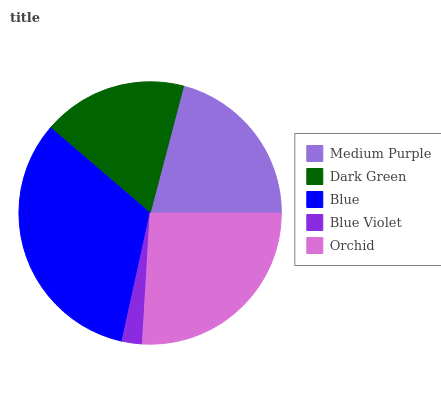Is Blue Violet the minimum?
Answer yes or no. Yes. Is Blue the maximum?
Answer yes or no. Yes. Is Dark Green the minimum?
Answer yes or no. No. Is Dark Green the maximum?
Answer yes or no. No. Is Medium Purple greater than Dark Green?
Answer yes or no. Yes. Is Dark Green less than Medium Purple?
Answer yes or no. Yes. Is Dark Green greater than Medium Purple?
Answer yes or no. No. Is Medium Purple less than Dark Green?
Answer yes or no. No. Is Medium Purple the high median?
Answer yes or no. Yes. Is Medium Purple the low median?
Answer yes or no. Yes. Is Orchid the high median?
Answer yes or no. No. Is Orchid the low median?
Answer yes or no. No. 